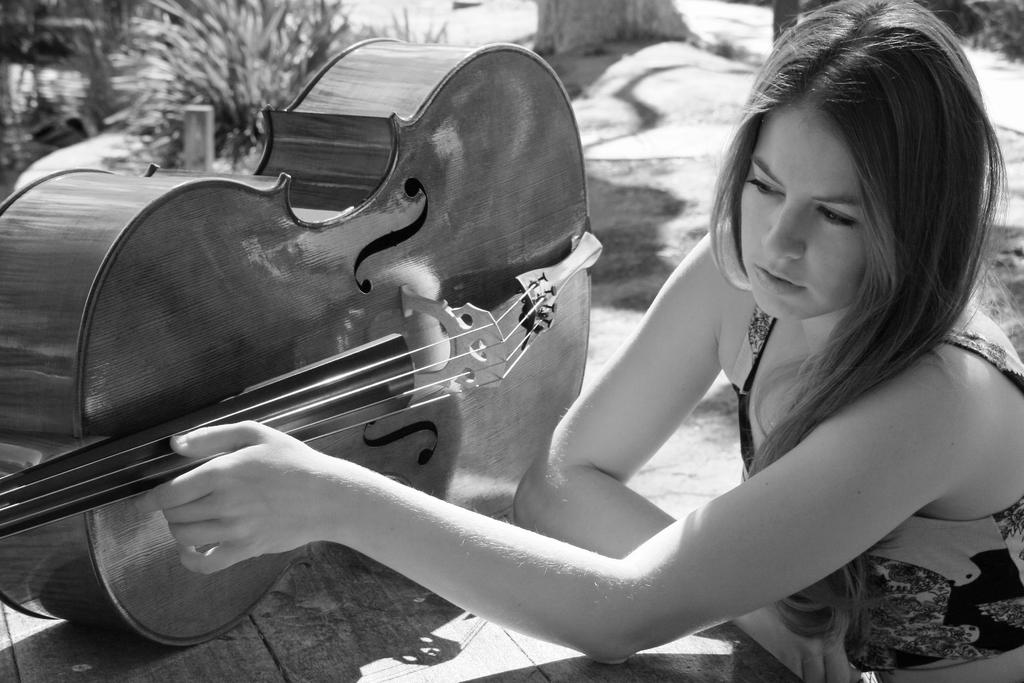Who is the main subject in the image? There is a lady in the image. What is the lady doing in the image? The lady is touching a guitar. What object is present on the table in the image? The guitar is placed on the table. How many planes can be seen flying in the image? There are: There are no planes visible in the image; it features a lady touching a guitar on a table. 